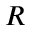<formula> <loc_0><loc_0><loc_500><loc_500>R</formula> 